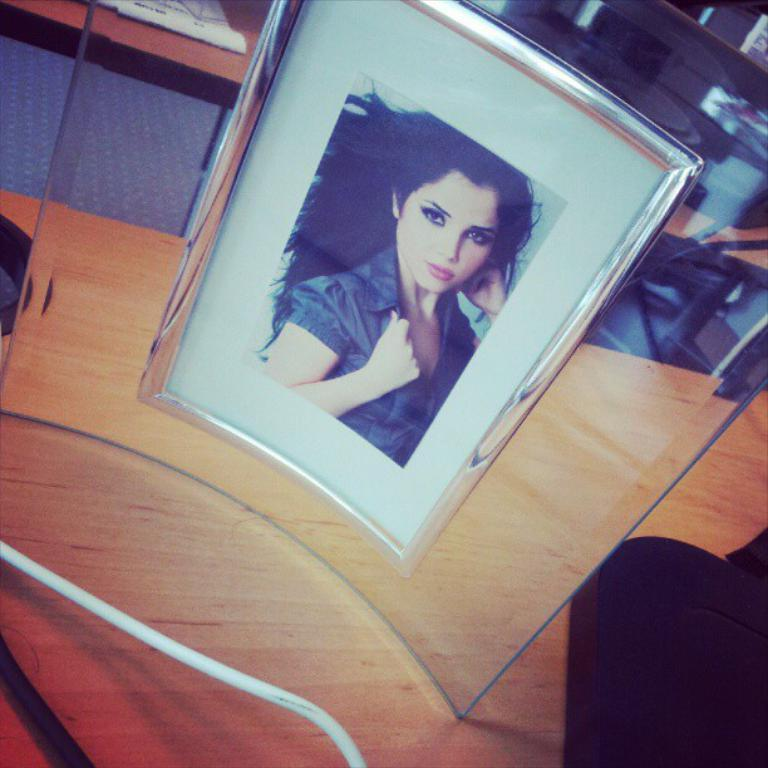What is on the wooden table in the image? There is a photo frame of a woman and a black colored object on the wooden table. What can be seen in the photo frame? The photo frame contains an image of a woman. Are there any other objects or items on the wooden table? No specific details about other objects on the wooden table are provided. What is present on the other table mentioned in the facts? Papers are present on another table. What type of flower is placed on the lace tablecloth in the image? There is no flower or lace tablecloth present in the image. How many plants are visible on the wooden table? There are no plants visible on the wooden table in the image. 